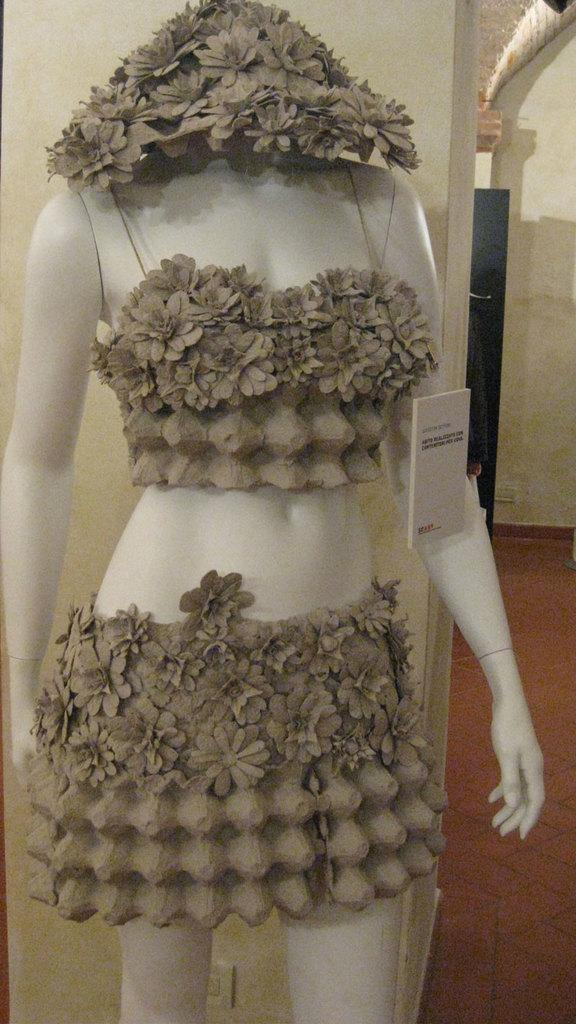What is the main subject in the image? There is a mannequin in the image. What is the purpose of the name board in the image? The name board in the image is likely used for identification or displaying information. What can be seen in the background of the image? There is a pillar, a wall, and a black color object visible in the background of the image. What type of surface is visible in the image? There is a floor visible in the image. Can you tell me how many loaves of bread are on the floor in the image? There is no loaf of bread present in the image; it features a mannequin, a name board, a pillar, a wall, a black color object, and a floor. 